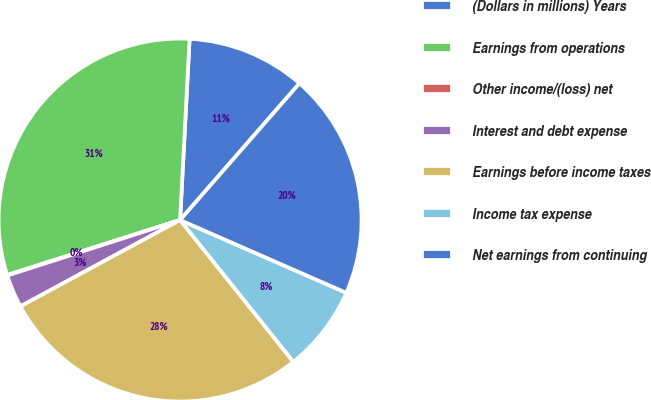Convert chart. <chart><loc_0><loc_0><loc_500><loc_500><pie_chart><fcel>(Dollars in millions) Years<fcel>Earnings from operations<fcel>Other income/(loss) net<fcel>Interest and debt expense<fcel>Earnings before income taxes<fcel>Income tax expense<fcel>Net earnings from continuing<nl><fcel>10.59%<fcel>30.73%<fcel>0.05%<fcel>2.94%<fcel>27.84%<fcel>7.7%<fcel>20.14%<nl></chart> 